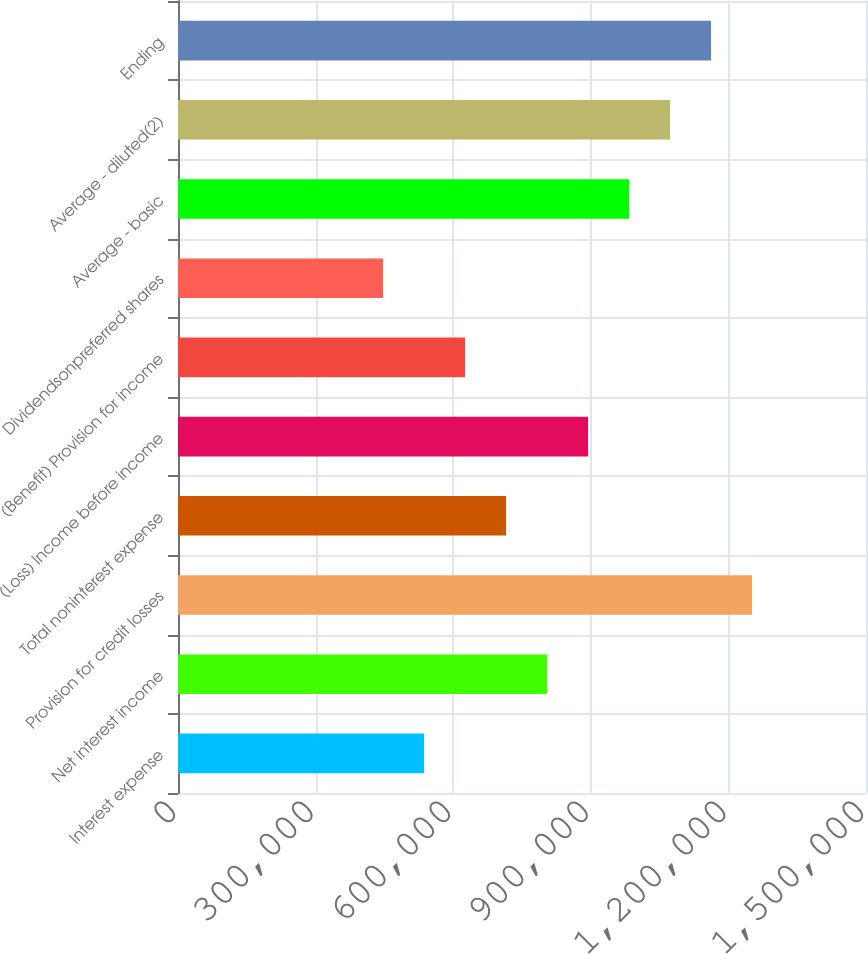<chart> <loc_0><loc_0><loc_500><loc_500><bar_chart><fcel>Interest expense<fcel>Net interest income<fcel>Provision for credit losses<fcel>Total noninterest expense<fcel>(Loss) Income before income<fcel>(Benefit) Provision for income<fcel>Dividendsonpreferred shares<fcel>Average - basic<fcel>Average - diluted(2)<fcel>Ending<nl><fcel>536395<fcel>804592<fcel>1.25159e+06<fcel>715193<fcel>893991<fcel>625794<fcel>446996<fcel>983390<fcel>1.07279e+06<fcel>1.16219e+06<nl></chart> 